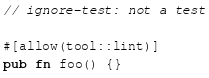<code> <loc_0><loc_0><loc_500><loc_500><_Rust_>// ignore-test: not a test

#[allow(tool::lint)]
pub fn foo() {}
</code> 